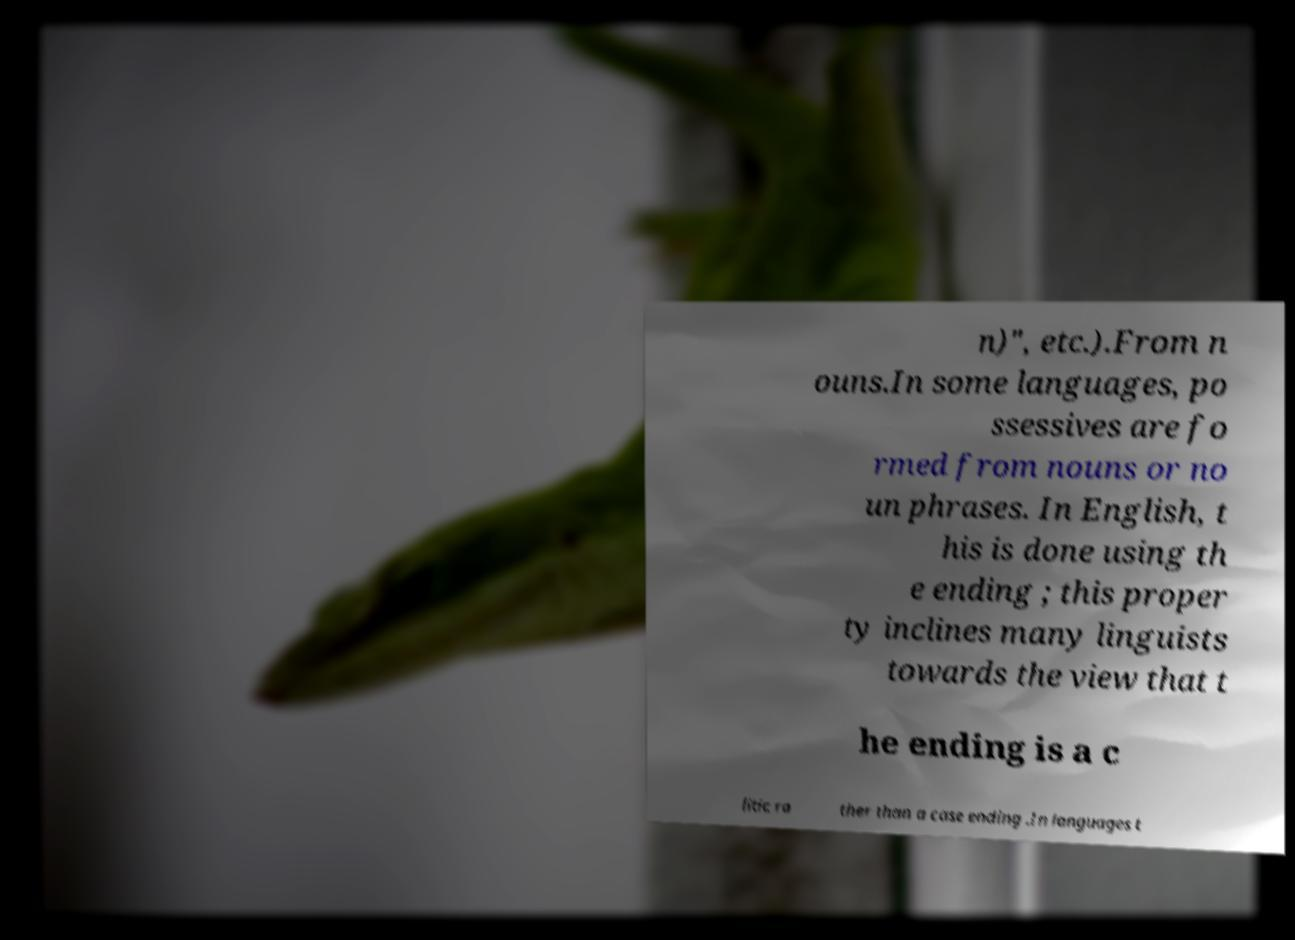Please identify and transcribe the text found in this image. n)", etc.).From n ouns.In some languages, po ssessives are fo rmed from nouns or no un phrases. In English, t his is done using th e ending ; this proper ty inclines many linguists towards the view that t he ending is a c litic ra ther than a case ending .In languages t 